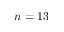Convert formula to latex. <formula><loc_0><loc_0><loc_500><loc_500>n = 1 3</formula> 